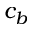Convert formula to latex. <formula><loc_0><loc_0><loc_500><loc_500>c _ { b }</formula> 